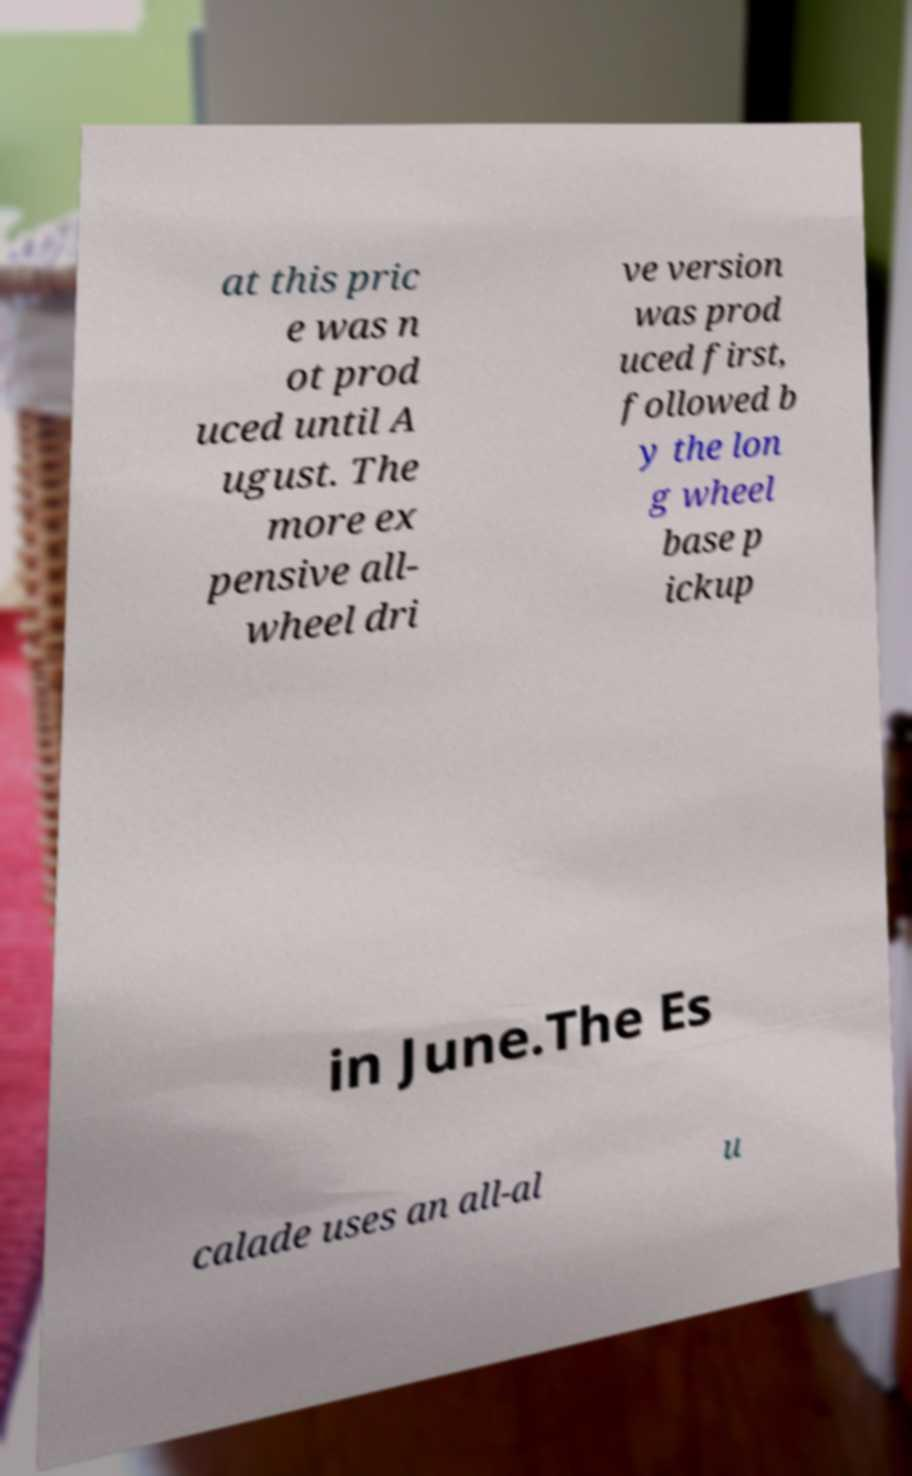I need the written content from this picture converted into text. Can you do that? at this pric e was n ot prod uced until A ugust. The more ex pensive all- wheel dri ve version was prod uced first, followed b y the lon g wheel base p ickup in June.The Es calade uses an all-al u 